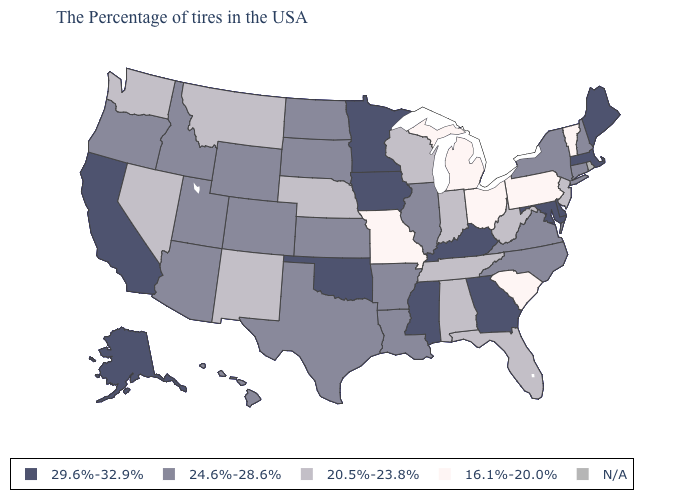What is the lowest value in the USA?
Quick response, please. 16.1%-20.0%. What is the value of Virginia?
Short answer required. 24.6%-28.6%. What is the value of New York?
Short answer required. 24.6%-28.6%. Name the states that have a value in the range 29.6%-32.9%?
Short answer required. Maine, Massachusetts, Delaware, Maryland, Georgia, Kentucky, Mississippi, Minnesota, Iowa, Oklahoma, California, Alaska. Among the states that border Kansas , does Missouri have the lowest value?
Be succinct. Yes. Among the states that border Pennsylvania , which have the highest value?
Quick response, please. Delaware, Maryland. What is the highest value in the Northeast ?
Concise answer only. 29.6%-32.9%. Among the states that border Utah , which have the highest value?
Give a very brief answer. Wyoming, Colorado, Arizona, Idaho. What is the value of Maryland?
Concise answer only. 29.6%-32.9%. Does Wisconsin have the lowest value in the USA?
Be succinct. No. What is the value of Ohio?
Quick response, please. 16.1%-20.0%. What is the value of North Dakota?
Keep it brief. 24.6%-28.6%. What is the lowest value in the USA?
Answer briefly. 16.1%-20.0%. Among the states that border Missouri , does Tennessee have the lowest value?
Give a very brief answer. Yes. 